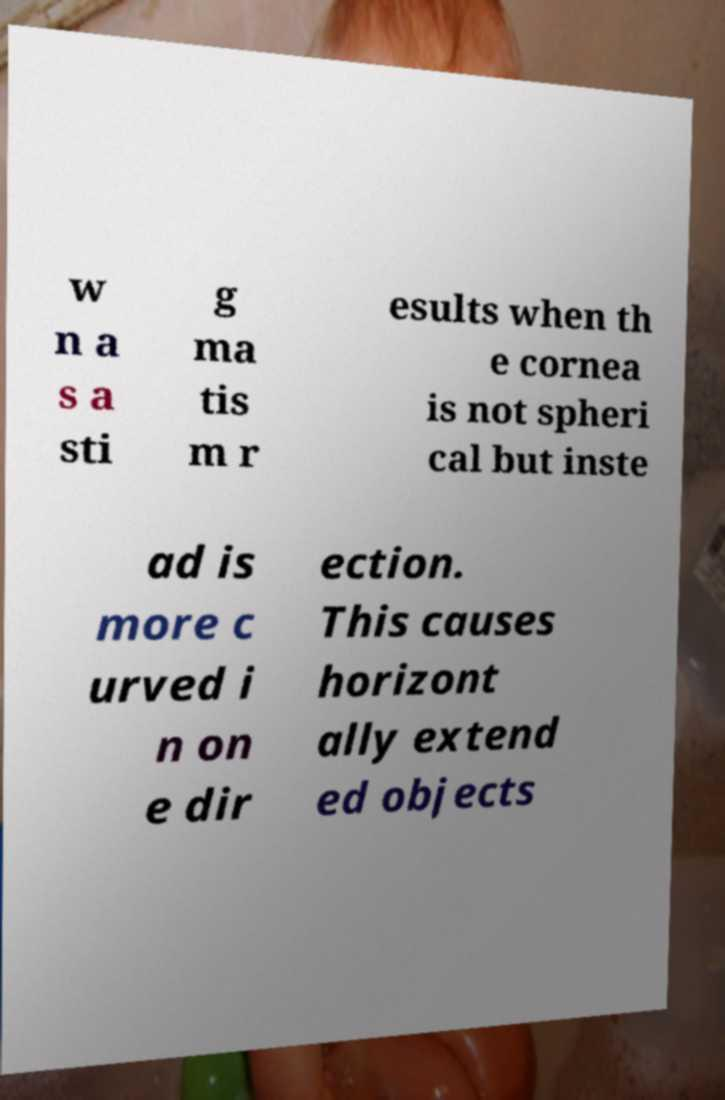For documentation purposes, I need the text within this image transcribed. Could you provide that? w n a s a sti g ma tis m r esults when th e cornea is not spheri cal but inste ad is more c urved i n on e dir ection. This causes horizont ally extend ed objects 